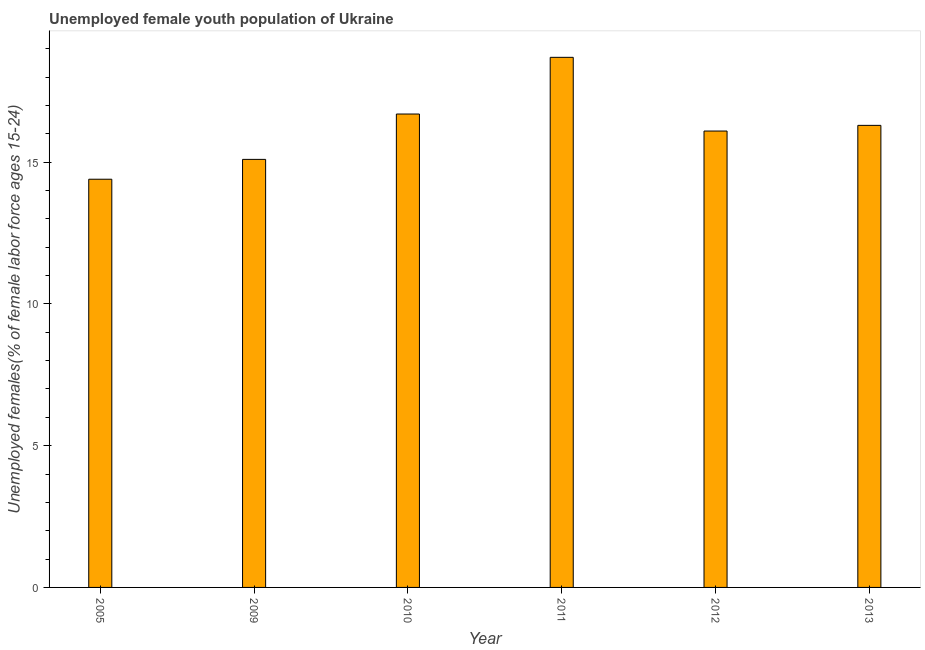Does the graph contain any zero values?
Your answer should be compact. No. Does the graph contain grids?
Provide a succinct answer. No. What is the title of the graph?
Make the answer very short. Unemployed female youth population of Ukraine. What is the label or title of the X-axis?
Keep it short and to the point. Year. What is the label or title of the Y-axis?
Provide a short and direct response. Unemployed females(% of female labor force ages 15-24). What is the unemployed female youth in 2013?
Your answer should be very brief. 16.3. Across all years, what is the maximum unemployed female youth?
Ensure brevity in your answer.  18.7. Across all years, what is the minimum unemployed female youth?
Your answer should be compact. 14.4. In which year was the unemployed female youth maximum?
Ensure brevity in your answer.  2011. In which year was the unemployed female youth minimum?
Offer a very short reply. 2005. What is the sum of the unemployed female youth?
Offer a very short reply. 97.3. What is the difference between the unemployed female youth in 2011 and 2013?
Provide a short and direct response. 2.4. What is the average unemployed female youth per year?
Provide a succinct answer. 16.22. What is the median unemployed female youth?
Provide a succinct answer. 16.2. What is the ratio of the unemployed female youth in 2005 to that in 2011?
Provide a succinct answer. 0.77. Is the unemployed female youth in 2005 less than that in 2011?
Keep it short and to the point. Yes. What is the difference between the highest and the second highest unemployed female youth?
Keep it short and to the point. 2. Is the sum of the unemployed female youth in 2005 and 2009 greater than the maximum unemployed female youth across all years?
Keep it short and to the point. Yes. What is the difference between the highest and the lowest unemployed female youth?
Your response must be concise. 4.3. In how many years, is the unemployed female youth greater than the average unemployed female youth taken over all years?
Your answer should be very brief. 3. Are all the bars in the graph horizontal?
Make the answer very short. No. What is the difference between two consecutive major ticks on the Y-axis?
Ensure brevity in your answer.  5. Are the values on the major ticks of Y-axis written in scientific E-notation?
Provide a succinct answer. No. What is the Unemployed females(% of female labor force ages 15-24) in 2005?
Give a very brief answer. 14.4. What is the Unemployed females(% of female labor force ages 15-24) in 2009?
Offer a terse response. 15.1. What is the Unemployed females(% of female labor force ages 15-24) of 2010?
Offer a very short reply. 16.7. What is the Unemployed females(% of female labor force ages 15-24) in 2011?
Provide a short and direct response. 18.7. What is the Unemployed females(% of female labor force ages 15-24) of 2012?
Make the answer very short. 16.1. What is the Unemployed females(% of female labor force ages 15-24) of 2013?
Your response must be concise. 16.3. What is the difference between the Unemployed females(% of female labor force ages 15-24) in 2005 and 2010?
Your answer should be compact. -2.3. What is the difference between the Unemployed females(% of female labor force ages 15-24) in 2009 and 2010?
Keep it short and to the point. -1.6. What is the difference between the Unemployed females(% of female labor force ages 15-24) in 2009 and 2012?
Your response must be concise. -1. What is the difference between the Unemployed females(% of female labor force ages 15-24) in 2009 and 2013?
Offer a very short reply. -1.2. What is the difference between the Unemployed females(% of female labor force ages 15-24) in 2011 and 2012?
Offer a terse response. 2.6. What is the difference between the Unemployed females(% of female labor force ages 15-24) in 2011 and 2013?
Your answer should be compact. 2.4. What is the difference between the Unemployed females(% of female labor force ages 15-24) in 2012 and 2013?
Ensure brevity in your answer.  -0.2. What is the ratio of the Unemployed females(% of female labor force ages 15-24) in 2005 to that in 2009?
Provide a short and direct response. 0.95. What is the ratio of the Unemployed females(% of female labor force ages 15-24) in 2005 to that in 2010?
Ensure brevity in your answer.  0.86. What is the ratio of the Unemployed females(% of female labor force ages 15-24) in 2005 to that in 2011?
Make the answer very short. 0.77. What is the ratio of the Unemployed females(% of female labor force ages 15-24) in 2005 to that in 2012?
Your answer should be compact. 0.89. What is the ratio of the Unemployed females(% of female labor force ages 15-24) in 2005 to that in 2013?
Offer a terse response. 0.88. What is the ratio of the Unemployed females(% of female labor force ages 15-24) in 2009 to that in 2010?
Provide a succinct answer. 0.9. What is the ratio of the Unemployed females(% of female labor force ages 15-24) in 2009 to that in 2011?
Provide a succinct answer. 0.81. What is the ratio of the Unemployed females(% of female labor force ages 15-24) in 2009 to that in 2012?
Your answer should be very brief. 0.94. What is the ratio of the Unemployed females(% of female labor force ages 15-24) in 2009 to that in 2013?
Keep it short and to the point. 0.93. What is the ratio of the Unemployed females(% of female labor force ages 15-24) in 2010 to that in 2011?
Your answer should be compact. 0.89. What is the ratio of the Unemployed females(% of female labor force ages 15-24) in 2010 to that in 2012?
Give a very brief answer. 1.04. What is the ratio of the Unemployed females(% of female labor force ages 15-24) in 2011 to that in 2012?
Offer a terse response. 1.16. What is the ratio of the Unemployed females(% of female labor force ages 15-24) in 2011 to that in 2013?
Provide a short and direct response. 1.15. 